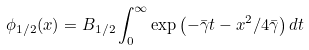Convert formula to latex. <formula><loc_0><loc_0><loc_500><loc_500>\phi _ { 1 / 2 } ( x ) = B _ { 1 / 2 } \int _ { 0 } ^ { \infty } \exp \left ( - \bar { \gamma } t - x ^ { 2 } / { 4 \bar { \gamma } } \right ) d t</formula> 